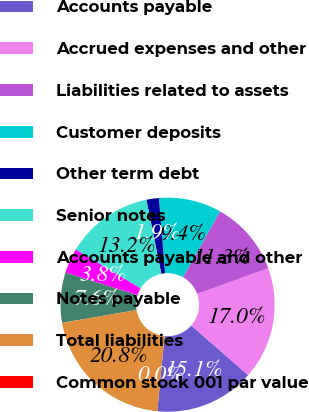Convert chart. <chart><loc_0><loc_0><loc_500><loc_500><pie_chart><fcel>Accounts payable<fcel>Accrued expenses and other<fcel>Liabilities related to assets<fcel>Customer deposits<fcel>Other term debt<fcel>Senior notes<fcel>Accounts payable and other<fcel>Notes payable<fcel>Total liabilities<fcel>Common stock 001 par value<nl><fcel>15.09%<fcel>16.98%<fcel>11.32%<fcel>9.43%<fcel>1.89%<fcel>13.21%<fcel>3.77%<fcel>7.55%<fcel>20.75%<fcel>0.0%<nl></chart> 